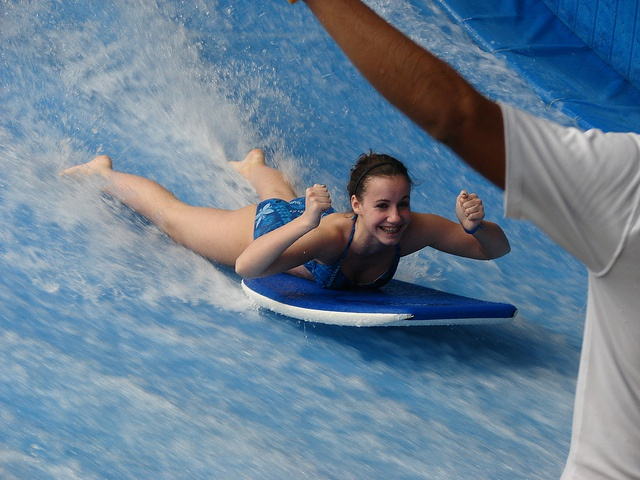Describe the objects in this image and their specific colors. I can see people in gray, black, and tan tones, people in gray, darkgray, maroon, and black tones, and surfboard in gray, navy, black, lightgray, and blue tones in this image. 